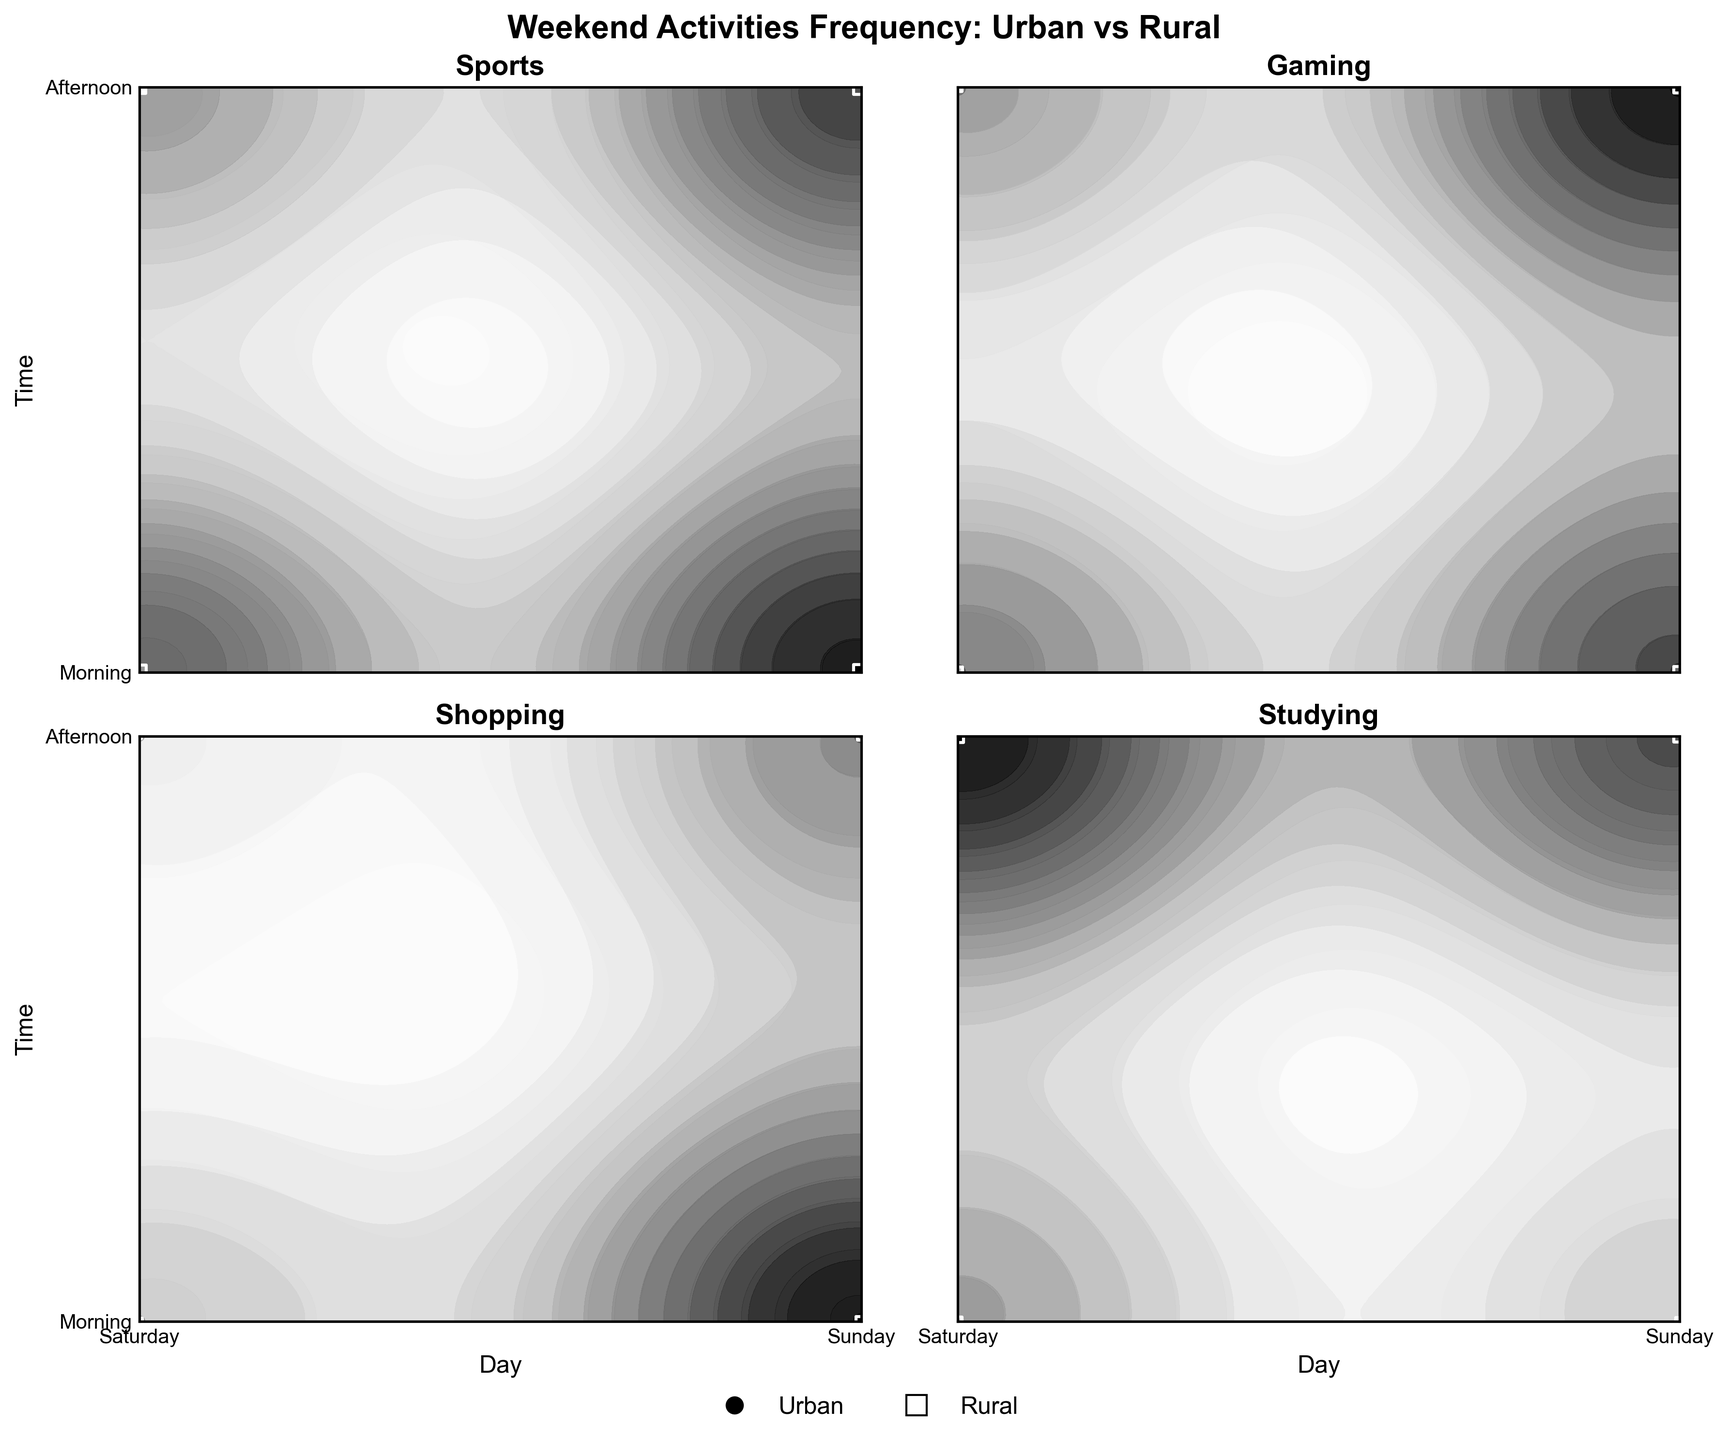How many different activities are shown in the figure? The figure shows subplots for different categories of activities. By counting the subplots and reading the titles within each, we can determine the number of activities represented.
Answer: 4 What is the most frequent activity for rural teenagers on Saturday afternoon? To determine the most frequent activity, we need to look at the frequency data for each activity in rural areas on Saturday afternoon. By comparing these values, we find the highest frequency.
Answer: Sports Which activity has a higher frequency in rural areas compared to urban areas across all times? By comparing the frequencies across rural and urban areas for all times for each activity, we need to find the activity that consistently shows a higher value in rural locations.
Answer: Sports On which day and time is gaming more popular in urban areas? To find when gaming is most popular in urban areas, we need to look at the contour plot for gaming in urban locations and identify the highest frequency value along both the day and time axes.
Answer: Sunday Afternoon What is the least frequent activity for urban teenagers on Sunday morning? To identify the least frequent activity, we should look at the frequency data for each activity in urban areas on Sunday morning and find the activity with the lowest value.
Answer: Shopping How does the frequency of studying in rural areas change from Saturday morning to Sunday afternoon? By tracking the frequency values for studying in rural areas across Saturday morning, Saturday afternoon, Sunday morning, and Sunday afternoon, we observe the trend and changes over these times.
Answer: Increasing Is shopping more popular in urban or rural areas on Saturday morning? By comparing the frequency values of shopping in urban and rural areas on Saturday morning, we can determine which location has a higher frequency.
Answer: Urban Which activity shows the greatest difference in frequency between urban and rural areas on Sunday afternoon? By calculating the difference in frequency values for each activity between urban and rural areas on Sunday afternoon, we identify the activity with the largest discrepancy.
Answer: Sports 